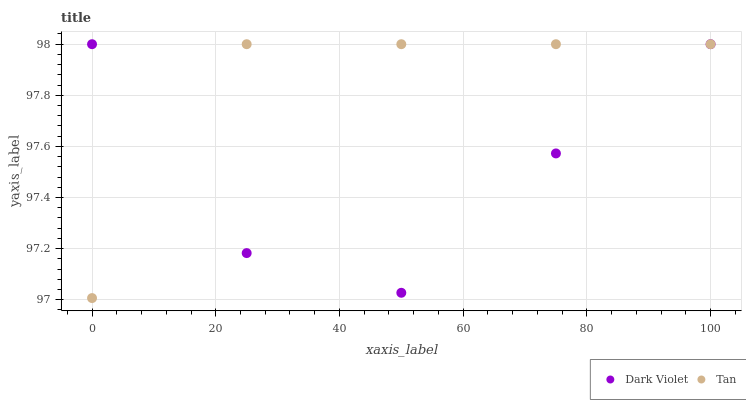Does Dark Violet have the minimum area under the curve?
Answer yes or no. Yes. Does Tan have the maximum area under the curve?
Answer yes or no. Yes. Does Dark Violet have the maximum area under the curve?
Answer yes or no. No. Is Tan the smoothest?
Answer yes or no. Yes. Is Dark Violet the roughest?
Answer yes or no. Yes. Is Dark Violet the smoothest?
Answer yes or no. No. Does Tan have the lowest value?
Answer yes or no. Yes. Does Dark Violet have the lowest value?
Answer yes or no. No. Does Dark Violet have the highest value?
Answer yes or no. Yes. Does Dark Violet intersect Tan?
Answer yes or no. Yes. Is Dark Violet less than Tan?
Answer yes or no. No. Is Dark Violet greater than Tan?
Answer yes or no. No. 